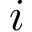<formula> <loc_0><loc_0><loc_500><loc_500>i</formula> 